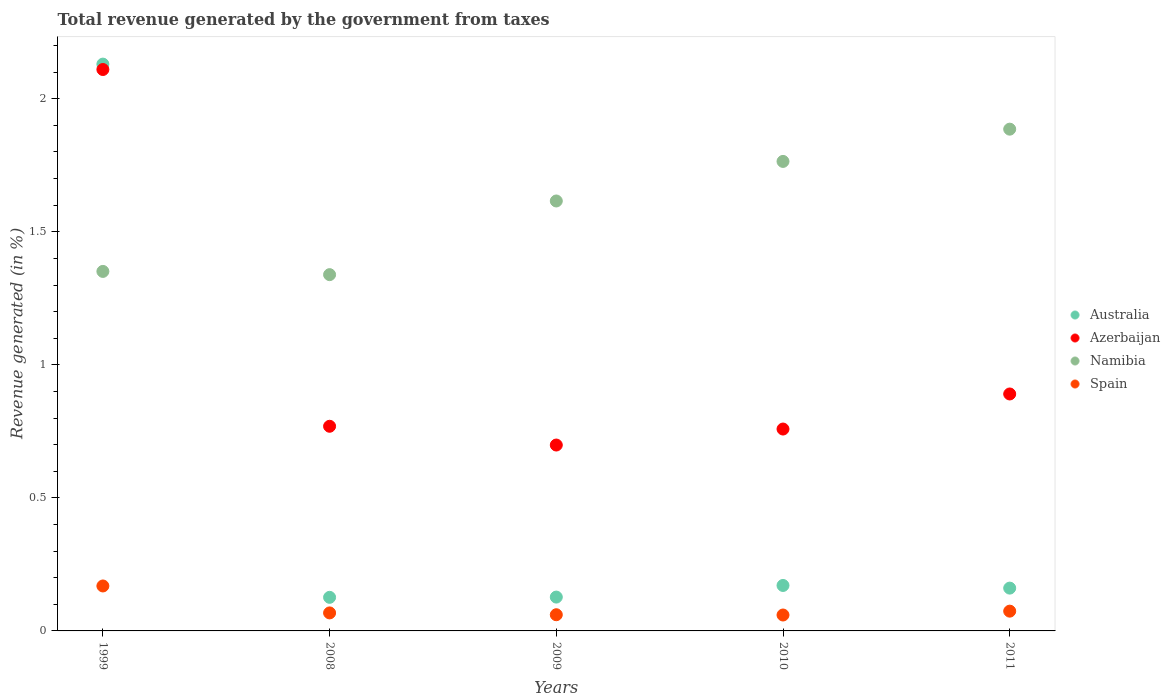Is the number of dotlines equal to the number of legend labels?
Your response must be concise. Yes. What is the total revenue generated in Spain in 1999?
Your answer should be very brief. 0.17. Across all years, what is the maximum total revenue generated in Namibia?
Keep it short and to the point. 1.89. Across all years, what is the minimum total revenue generated in Azerbaijan?
Your answer should be compact. 0.7. In which year was the total revenue generated in Spain maximum?
Your answer should be very brief. 1999. What is the total total revenue generated in Namibia in the graph?
Provide a succinct answer. 7.96. What is the difference between the total revenue generated in Australia in 2008 and that in 2011?
Offer a very short reply. -0.03. What is the difference between the total revenue generated in Australia in 2009 and the total revenue generated in Spain in 2008?
Your response must be concise. 0.06. What is the average total revenue generated in Azerbaijan per year?
Make the answer very short. 1.05. In the year 2008, what is the difference between the total revenue generated in Namibia and total revenue generated in Australia?
Your answer should be very brief. 1.21. In how many years, is the total revenue generated in Spain greater than 0.8 %?
Give a very brief answer. 0. What is the ratio of the total revenue generated in Australia in 2009 to that in 2011?
Your response must be concise. 0.79. Is the total revenue generated in Namibia in 2008 less than that in 2011?
Offer a terse response. Yes. What is the difference between the highest and the second highest total revenue generated in Spain?
Keep it short and to the point. 0.09. What is the difference between the highest and the lowest total revenue generated in Spain?
Give a very brief answer. 0.11. Is the sum of the total revenue generated in Australia in 2008 and 2011 greater than the maximum total revenue generated in Azerbaijan across all years?
Your answer should be very brief. No. Is the total revenue generated in Azerbaijan strictly greater than the total revenue generated in Spain over the years?
Your answer should be very brief. Yes. Is the total revenue generated in Spain strictly less than the total revenue generated in Australia over the years?
Provide a short and direct response. Yes. How many dotlines are there?
Your answer should be compact. 4. What is the difference between two consecutive major ticks on the Y-axis?
Ensure brevity in your answer.  0.5. Where does the legend appear in the graph?
Keep it short and to the point. Center right. What is the title of the graph?
Make the answer very short. Total revenue generated by the government from taxes. What is the label or title of the Y-axis?
Make the answer very short. Revenue generated (in %). What is the Revenue generated (in %) of Australia in 1999?
Your answer should be compact. 2.13. What is the Revenue generated (in %) in Azerbaijan in 1999?
Ensure brevity in your answer.  2.11. What is the Revenue generated (in %) of Namibia in 1999?
Make the answer very short. 1.35. What is the Revenue generated (in %) of Spain in 1999?
Give a very brief answer. 0.17. What is the Revenue generated (in %) in Australia in 2008?
Provide a short and direct response. 0.13. What is the Revenue generated (in %) of Azerbaijan in 2008?
Make the answer very short. 0.77. What is the Revenue generated (in %) of Namibia in 2008?
Keep it short and to the point. 1.34. What is the Revenue generated (in %) in Spain in 2008?
Ensure brevity in your answer.  0.07. What is the Revenue generated (in %) of Australia in 2009?
Your answer should be very brief. 0.13. What is the Revenue generated (in %) of Azerbaijan in 2009?
Offer a very short reply. 0.7. What is the Revenue generated (in %) of Namibia in 2009?
Your response must be concise. 1.62. What is the Revenue generated (in %) in Spain in 2009?
Give a very brief answer. 0.06. What is the Revenue generated (in %) of Australia in 2010?
Ensure brevity in your answer.  0.17. What is the Revenue generated (in %) in Azerbaijan in 2010?
Your answer should be very brief. 0.76. What is the Revenue generated (in %) of Namibia in 2010?
Offer a terse response. 1.76. What is the Revenue generated (in %) of Spain in 2010?
Ensure brevity in your answer.  0.06. What is the Revenue generated (in %) of Australia in 2011?
Ensure brevity in your answer.  0.16. What is the Revenue generated (in %) of Azerbaijan in 2011?
Your answer should be compact. 0.89. What is the Revenue generated (in %) of Namibia in 2011?
Offer a very short reply. 1.89. What is the Revenue generated (in %) in Spain in 2011?
Provide a short and direct response. 0.07. Across all years, what is the maximum Revenue generated (in %) in Australia?
Your answer should be very brief. 2.13. Across all years, what is the maximum Revenue generated (in %) of Azerbaijan?
Keep it short and to the point. 2.11. Across all years, what is the maximum Revenue generated (in %) in Namibia?
Ensure brevity in your answer.  1.89. Across all years, what is the maximum Revenue generated (in %) of Spain?
Your response must be concise. 0.17. Across all years, what is the minimum Revenue generated (in %) in Australia?
Your response must be concise. 0.13. Across all years, what is the minimum Revenue generated (in %) in Azerbaijan?
Give a very brief answer. 0.7. Across all years, what is the minimum Revenue generated (in %) of Namibia?
Your response must be concise. 1.34. Across all years, what is the minimum Revenue generated (in %) of Spain?
Your response must be concise. 0.06. What is the total Revenue generated (in %) of Australia in the graph?
Offer a very short reply. 2.72. What is the total Revenue generated (in %) in Azerbaijan in the graph?
Make the answer very short. 5.23. What is the total Revenue generated (in %) of Namibia in the graph?
Keep it short and to the point. 7.96. What is the total Revenue generated (in %) of Spain in the graph?
Your response must be concise. 0.43. What is the difference between the Revenue generated (in %) in Australia in 1999 and that in 2008?
Provide a short and direct response. 2. What is the difference between the Revenue generated (in %) in Azerbaijan in 1999 and that in 2008?
Provide a short and direct response. 1.34. What is the difference between the Revenue generated (in %) in Namibia in 1999 and that in 2008?
Provide a short and direct response. 0.01. What is the difference between the Revenue generated (in %) of Spain in 1999 and that in 2008?
Offer a very short reply. 0.1. What is the difference between the Revenue generated (in %) of Australia in 1999 and that in 2009?
Your answer should be very brief. 2. What is the difference between the Revenue generated (in %) of Azerbaijan in 1999 and that in 2009?
Provide a short and direct response. 1.41. What is the difference between the Revenue generated (in %) in Namibia in 1999 and that in 2009?
Make the answer very short. -0.26. What is the difference between the Revenue generated (in %) of Spain in 1999 and that in 2009?
Keep it short and to the point. 0.11. What is the difference between the Revenue generated (in %) of Australia in 1999 and that in 2010?
Provide a short and direct response. 1.96. What is the difference between the Revenue generated (in %) in Azerbaijan in 1999 and that in 2010?
Offer a terse response. 1.35. What is the difference between the Revenue generated (in %) in Namibia in 1999 and that in 2010?
Provide a short and direct response. -0.41. What is the difference between the Revenue generated (in %) of Spain in 1999 and that in 2010?
Make the answer very short. 0.11. What is the difference between the Revenue generated (in %) of Australia in 1999 and that in 2011?
Your response must be concise. 1.97. What is the difference between the Revenue generated (in %) in Azerbaijan in 1999 and that in 2011?
Provide a short and direct response. 1.22. What is the difference between the Revenue generated (in %) of Namibia in 1999 and that in 2011?
Make the answer very short. -0.53. What is the difference between the Revenue generated (in %) in Spain in 1999 and that in 2011?
Your response must be concise. 0.09. What is the difference between the Revenue generated (in %) of Australia in 2008 and that in 2009?
Provide a short and direct response. -0. What is the difference between the Revenue generated (in %) in Azerbaijan in 2008 and that in 2009?
Provide a succinct answer. 0.07. What is the difference between the Revenue generated (in %) in Namibia in 2008 and that in 2009?
Ensure brevity in your answer.  -0.28. What is the difference between the Revenue generated (in %) in Spain in 2008 and that in 2009?
Your answer should be compact. 0.01. What is the difference between the Revenue generated (in %) of Australia in 2008 and that in 2010?
Keep it short and to the point. -0.04. What is the difference between the Revenue generated (in %) in Azerbaijan in 2008 and that in 2010?
Your response must be concise. 0.01. What is the difference between the Revenue generated (in %) in Namibia in 2008 and that in 2010?
Your answer should be compact. -0.43. What is the difference between the Revenue generated (in %) of Spain in 2008 and that in 2010?
Make the answer very short. 0.01. What is the difference between the Revenue generated (in %) of Australia in 2008 and that in 2011?
Your answer should be compact. -0.03. What is the difference between the Revenue generated (in %) in Azerbaijan in 2008 and that in 2011?
Offer a terse response. -0.12. What is the difference between the Revenue generated (in %) in Namibia in 2008 and that in 2011?
Your answer should be very brief. -0.55. What is the difference between the Revenue generated (in %) in Spain in 2008 and that in 2011?
Your answer should be compact. -0.01. What is the difference between the Revenue generated (in %) in Australia in 2009 and that in 2010?
Offer a terse response. -0.04. What is the difference between the Revenue generated (in %) in Azerbaijan in 2009 and that in 2010?
Give a very brief answer. -0.06. What is the difference between the Revenue generated (in %) in Namibia in 2009 and that in 2010?
Give a very brief answer. -0.15. What is the difference between the Revenue generated (in %) of Australia in 2009 and that in 2011?
Ensure brevity in your answer.  -0.03. What is the difference between the Revenue generated (in %) in Azerbaijan in 2009 and that in 2011?
Make the answer very short. -0.19. What is the difference between the Revenue generated (in %) in Namibia in 2009 and that in 2011?
Give a very brief answer. -0.27. What is the difference between the Revenue generated (in %) in Spain in 2009 and that in 2011?
Offer a very short reply. -0.01. What is the difference between the Revenue generated (in %) in Australia in 2010 and that in 2011?
Your response must be concise. 0.01. What is the difference between the Revenue generated (in %) in Azerbaijan in 2010 and that in 2011?
Provide a succinct answer. -0.13. What is the difference between the Revenue generated (in %) in Namibia in 2010 and that in 2011?
Provide a short and direct response. -0.12. What is the difference between the Revenue generated (in %) of Spain in 2010 and that in 2011?
Offer a very short reply. -0.01. What is the difference between the Revenue generated (in %) of Australia in 1999 and the Revenue generated (in %) of Azerbaijan in 2008?
Your answer should be compact. 1.36. What is the difference between the Revenue generated (in %) in Australia in 1999 and the Revenue generated (in %) in Namibia in 2008?
Provide a succinct answer. 0.79. What is the difference between the Revenue generated (in %) of Australia in 1999 and the Revenue generated (in %) of Spain in 2008?
Ensure brevity in your answer.  2.06. What is the difference between the Revenue generated (in %) of Azerbaijan in 1999 and the Revenue generated (in %) of Namibia in 2008?
Ensure brevity in your answer.  0.77. What is the difference between the Revenue generated (in %) of Azerbaijan in 1999 and the Revenue generated (in %) of Spain in 2008?
Your answer should be very brief. 2.04. What is the difference between the Revenue generated (in %) in Namibia in 1999 and the Revenue generated (in %) in Spain in 2008?
Offer a very short reply. 1.28. What is the difference between the Revenue generated (in %) in Australia in 1999 and the Revenue generated (in %) in Azerbaijan in 2009?
Your answer should be very brief. 1.43. What is the difference between the Revenue generated (in %) of Australia in 1999 and the Revenue generated (in %) of Namibia in 2009?
Provide a succinct answer. 0.51. What is the difference between the Revenue generated (in %) of Australia in 1999 and the Revenue generated (in %) of Spain in 2009?
Keep it short and to the point. 2.07. What is the difference between the Revenue generated (in %) in Azerbaijan in 1999 and the Revenue generated (in %) in Namibia in 2009?
Offer a terse response. 0.49. What is the difference between the Revenue generated (in %) of Azerbaijan in 1999 and the Revenue generated (in %) of Spain in 2009?
Your answer should be very brief. 2.05. What is the difference between the Revenue generated (in %) of Namibia in 1999 and the Revenue generated (in %) of Spain in 2009?
Your response must be concise. 1.29. What is the difference between the Revenue generated (in %) in Australia in 1999 and the Revenue generated (in %) in Azerbaijan in 2010?
Ensure brevity in your answer.  1.37. What is the difference between the Revenue generated (in %) in Australia in 1999 and the Revenue generated (in %) in Namibia in 2010?
Make the answer very short. 0.37. What is the difference between the Revenue generated (in %) of Australia in 1999 and the Revenue generated (in %) of Spain in 2010?
Offer a terse response. 2.07. What is the difference between the Revenue generated (in %) in Azerbaijan in 1999 and the Revenue generated (in %) in Namibia in 2010?
Ensure brevity in your answer.  0.35. What is the difference between the Revenue generated (in %) of Azerbaijan in 1999 and the Revenue generated (in %) of Spain in 2010?
Offer a terse response. 2.05. What is the difference between the Revenue generated (in %) in Namibia in 1999 and the Revenue generated (in %) in Spain in 2010?
Provide a short and direct response. 1.29. What is the difference between the Revenue generated (in %) in Australia in 1999 and the Revenue generated (in %) in Azerbaijan in 2011?
Your answer should be compact. 1.24. What is the difference between the Revenue generated (in %) of Australia in 1999 and the Revenue generated (in %) of Namibia in 2011?
Make the answer very short. 0.24. What is the difference between the Revenue generated (in %) in Australia in 1999 and the Revenue generated (in %) in Spain in 2011?
Keep it short and to the point. 2.06. What is the difference between the Revenue generated (in %) in Azerbaijan in 1999 and the Revenue generated (in %) in Namibia in 2011?
Your answer should be compact. 0.22. What is the difference between the Revenue generated (in %) in Azerbaijan in 1999 and the Revenue generated (in %) in Spain in 2011?
Provide a short and direct response. 2.04. What is the difference between the Revenue generated (in %) of Namibia in 1999 and the Revenue generated (in %) of Spain in 2011?
Your response must be concise. 1.28. What is the difference between the Revenue generated (in %) in Australia in 2008 and the Revenue generated (in %) in Azerbaijan in 2009?
Offer a very short reply. -0.57. What is the difference between the Revenue generated (in %) in Australia in 2008 and the Revenue generated (in %) in Namibia in 2009?
Give a very brief answer. -1.49. What is the difference between the Revenue generated (in %) in Australia in 2008 and the Revenue generated (in %) in Spain in 2009?
Provide a short and direct response. 0.07. What is the difference between the Revenue generated (in %) of Azerbaijan in 2008 and the Revenue generated (in %) of Namibia in 2009?
Keep it short and to the point. -0.85. What is the difference between the Revenue generated (in %) of Azerbaijan in 2008 and the Revenue generated (in %) of Spain in 2009?
Provide a succinct answer. 0.71. What is the difference between the Revenue generated (in %) of Namibia in 2008 and the Revenue generated (in %) of Spain in 2009?
Offer a terse response. 1.28. What is the difference between the Revenue generated (in %) of Australia in 2008 and the Revenue generated (in %) of Azerbaijan in 2010?
Provide a short and direct response. -0.63. What is the difference between the Revenue generated (in %) in Australia in 2008 and the Revenue generated (in %) in Namibia in 2010?
Offer a very short reply. -1.64. What is the difference between the Revenue generated (in %) in Australia in 2008 and the Revenue generated (in %) in Spain in 2010?
Provide a short and direct response. 0.07. What is the difference between the Revenue generated (in %) in Azerbaijan in 2008 and the Revenue generated (in %) in Namibia in 2010?
Offer a terse response. -1. What is the difference between the Revenue generated (in %) in Azerbaijan in 2008 and the Revenue generated (in %) in Spain in 2010?
Make the answer very short. 0.71. What is the difference between the Revenue generated (in %) of Namibia in 2008 and the Revenue generated (in %) of Spain in 2010?
Keep it short and to the point. 1.28. What is the difference between the Revenue generated (in %) in Australia in 2008 and the Revenue generated (in %) in Azerbaijan in 2011?
Ensure brevity in your answer.  -0.76. What is the difference between the Revenue generated (in %) in Australia in 2008 and the Revenue generated (in %) in Namibia in 2011?
Make the answer very short. -1.76. What is the difference between the Revenue generated (in %) in Australia in 2008 and the Revenue generated (in %) in Spain in 2011?
Your answer should be very brief. 0.05. What is the difference between the Revenue generated (in %) in Azerbaijan in 2008 and the Revenue generated (in %) in Namibia in 2011?
Provide a short and direct response. -1.12. What is the difference between the Revenue generated (in %) of Azerbaijan in 2008 and the Revenue generated (in %) of Spain in 2011?
Your answer should be compact. 0.69. What is the difference between the Revenue generated (in %) of Namibia in 2008 and the Revenue generated (in %) of Spain in 2011?
Keep it short and to the point. 1.26. What is the difference between the Revenue generated (in %) of Australia in 2009 and the Revenue generated (in %) of Azerbaijan in 2010?
Keep it short and to the point. -0.63. What is the difference between the Revenue generated (in %) of Australia in 2009 and the Revenue generated (in %) of Namibia in 2010?
Your answer should be very brief. -1.64. What is the difference between the Revenue generated (in %) of Australia in 2009 and the Revenue generated (in %) of Spain in 2010?
Offer a terse response. 0.07. What is the difference between the Revenue generated (in %) in Azerbaijan in 2009 and the Revenue generated (in %) in Namibia in 2010?
Make the answer very short. -1.07. What is the difference between the Revenue generated (in %) of Azerbaijan in 2009 and the Revenue generated (in %) of Spain in 2010?
Provide a short and direct response. 0.64. What is the difference between the Revenue generated (in %) in Namibia in 2009 and the Revenue generated (in %) in Spain in 2010?
Give a very brief answer. 1.56. What is the difference between the Revenue generated (in %) of Australia in 2009 and the Revenue generated (in %) of Azerbaijan in 2011?
Provide a succinct answer. -0.76. What is the difference between the Revenue generated (in %) of Australia in 2009 and the Revenue generated (in %) of Namibia in 2011?
Make the answer very short. -1.76. What is the difference between the Revenue generated (in %) in Australia in 2009 and the Revenue generated (in %) in Spain in 2011?
Your response must be concise. 0.05. What is the difference between the Revenue generated (in %) of Azerbaijan in 2009 and the Revenue generated (in %) of Namibia in 2011?
Your response must be concise. -1.19. What is the difference between the Revenue generated (in %) in Azerbaijan in 2009 and the Revenue generated (in %) in Spain in 2011?
Your answer should be very brief. 0.62. What is the difference between the Revenue generated (in %) of Namibia in 2009 and the Revenue generated (in %) of Spain in 2011?
Your answer should be compact. 1.54. What is the difference between the Revenue generated (in %) of Australia in 2010 and the Revenue generated (in %) of Azerbaijan in 2011?
Make the answer very short. -0.72. What is the difference between the Revenue generated (in %) of Australia in 2010 and the Revenue generated (in %) of Namibia in 2011?
Provide a succinct answer. -1.71. What is the difference between the Revenue generated (in %) in Australia in 2010 and the Revenue generated (in %) in Spain in 2011?
Your answer should be compact. 0.1. What is the difference between the Revenue generated (in %) of Azerbaijan in 2010 and the Revenue generated (in %) of Namibia in 2011?
Keep it short and to the point. -1.13. What is the difference between the Revenue generated (in %) in Azerbaijan in 2010 and the Revenue generated (in %) in Spain in 2011?
Provide a succinct answer. 0.68. What is the difference between the Revenue generated (in %) in Namibia in 2010 and the Revenue generated (in %) in Spain in 2011?
Your response must be concise. 1.69. What is the average Revenue generated (in %) in Australia per year?
Keep it short and to the point. 0.54. What is the average Revenue generated (in %) in Azerbaijan per year?
Keep it short and to the point. 1.05. What is the average Revenue generated (in %) of Namibia per year?
Offer a very short reply. 1.59. What is the average Revenue generated (in %) in Spain per year?
Your response must be concise. 0.09. In the year 1999, what is the difference between the Revenue generated (in %) of Australia and Revenue generated (in %) of Azerbaijan?
Your answer should be very brief. 0.02. In the year 1999, what is the difference between the Revenue generated (in %) in Australia and Revenue generated (in %) in Namibia?
Provide a succinct answer. 0.78. In the year 1999, what is the difference between the Revenue generated (in %) in Australia and Revenue generated (in %) in Spain?
Your response must be concise. 1.96. In the year 1999, what is the difference between the Revenue generated (in %) of Azerbaijan and Revenue generated (in %) of Namibia?
Your response must be concise. 0.76. In the year 1999, what is the difference between the Revenue generated (in %) in Azerbaijan and Revenue generated (in %) in Spain?
Offer a terse response. 1.94. In the year 1999, what is the difference between the Revenue generated (in %) of Namibia and Revenue generated (in %) of Spain?
Keep it short and to the point. 1.18. In the year 2008, what is the difference between the Revenue generated (in %) in Australia and Revenue generated (in %) in Azerbaijan?
Make the answer very short. -0.64. In the year 2008, what is the difference between the Revenue generated (in %) in Australia and Revenue generated (in %) in Namibia?
Offer a very short reply. -1.21. In the year 2008, what is the difference between the Revenue generated (in %) in Australia and Revenue generated (in %) in Spain?
Give a very brief answer. 0.06. In the year 2008, what is the difference between the Revenue generated (in %) in Azerbaijan and Revenue generated (in %) in Namibia?
Offer a very short reply. -0.57. In the year 2008, what is the difference between the Revenue generated (in %) of Azerbaijan and Revenue generated (in %) of Spain?
Make the answer very short. 0.7. In the year 2008, what is the difference between the Revenue generated (in %) of Namibia and Revenue generated (in %) of Spain?
Give a very brief answer. 1.27. In the year 2009, what is the difference between the Revenue generated (in %) in Australia and Revenue generated (in %) in Azerbaijan?
Keep it short and to the point. -0.57. In the year 2009, what is the difference between the Revenue generated (in %) of Australia and Revenue generated (in %) of Namibia?
Provide a succinct answer. -1.49. In the year 2009, what is the difference between the Revenue generated (in %) of Australia and Revenue generated (in %) of Spain?
Ensure brevity in your answer.  0.07. In the year 2009, what is the difference between the Revenue generated (in %) of Azerbaijan and Revenue generated (in %) of Namibia?
Make the answer very short. -0.92. In the year 2009, what is the difference between the Revenue generated (in %) of Azerbaijan and Revenue generated (in %) of Spain?
Your response must be concise. 0.64. In the year 2009, what is the difference between the Revenue generated (in %) in Namibia and Revenue generated (in %) in Spain?
Offer a very short reply. 1.55. In the year 2010, what is the difference between the Revenue generated (in %) of Australia and Revenue generated (in %) of Azerbaijan?
Ensure brevity in your answer.  -0.59. In the year 2010, what is the difference between the Revenue generated (in %) in Australia and Revenue generated (in %) in Namibia?
Give a very brief answer. -1.59. In the year 2010, what is the difference between the Revenue generated (in %) in Australia and Revenue generated (in %) in Spain?
Give a very brief answer. 0.11. In the year 2010, what is the difference between the Revenue generated (in %) of Azerbaijan and Revenue generated (in %) of Namibia?
Ensure brevity in your answer.  -1.01. In the year 2010, what is the difference between the Revenue generated (in %) of Azerbaijan and Revenue generated (in %) of Spain?
Provide a succinct answer. 0.7. In the year 2010, what is the difference between the Revenue generated (in %) in Namibia and Revenue generated (in %) in Spain?
Keep it short and to the point. 1.7. In the year 2011, what is the difference between the Revenue generated (in %) of Australia and Revenue generated (in %) of Azerbaijan?
Your response must be concise. -0.73. In the year 2011, what is the difference between the Revenue generated (in %) in Australia and Revenue generated (in %) in Namibia?
Your answer should be compact. -1.72. In the year 2011, what is the difference between the Revenue generated (in %) in Australia and Revenue generated (in %) in Spain?
Ensure brevity in your answer.  0.09. In the year 2011, what is the difference between the Revenue generated (in %) of Azerbaijan and Revenue generated (in %) of Namibia?
Make the answer very short. -1. In the year 2011, what is the difference between the Revenue generated (in %) in Azerbaijan and Revenue generated (in %) in Spain?
Give a very brief answer. 0.82. In the year 2011, what is the difference between the Revenue generated (in %) in Namibia and Revenue generated (in %) in Spain?
Make the answer very short. 1.81. What is the ratio of the Revenue generated (in %) in Australia in 1999 to that in 2008?
Give a very brief answer. 16.88. What is the ratio of the Revenue generated (in %) of Azerbaijan in 1999 to that in 2008?
Make the answer very short. 2.74. What is the ratio of the Revenue generated (in %) of Namibia in 1999 to that in 2008?
Offer a very short reply. 1.01. What is the ratio of the Revenue generated (in %) of Spain in 1999 to that in 2008?
Your answer should be very brief. 2.5. What is the ratio of the Revenue generated (in %) in Australia in 1999 to that in 2009?
Ensure brevity in your answer.  16.75. What is the ratio of the Revenue generated (in %) of Azerbaijan in 1999 to that in 2009?
Provide a short and direct response. 3.02. What is the ratio of the Revenue generated (in %) in Namibia in 1999 to that in 2009?
Your answer should be compact. 0.84. What is the ratio of the Revenue generated (in %) in Spain in 1999 to that in 2009?
Your answer should be very brief. 2.78. What is the ratio of the Revenue generated (in %) of Australia in 1999 to that in 2010?
Make the answer very short. 12.47. What is the ratio of the Revenue generated (in %) in Azerbaijan in 1999 to that in 2010?
Ensure brevity in your answer.  2.78. What is the ratio of the Revenue generated (in %) of Namibia in 1999 to that in 2010?
Provide a short and direct response. 0.77. What is the ratio of the Revenue generated (in %) of Spain in 1999 to that in 2010?
Your response must be concise. 2.82. What is the ratio of the Revenue generated (in %) in Australia in 1999 to that in 2011?
Make the answer very short. 13.24. What is the ratio of the Revenue generated (in %) in Azerbaijan in 1999 to that in 2011?
Offer a terse response. 2.37. What is the ratio of the Revenue generated (in %) of Namibia in 1999 to that in 2011?
Make the answer very short. 0.72. What is the ratio of the Revenue generated (in %) in Spain in 1999 to that in 2011?
Provide a short and direct response. 2.27. What is the ratio of the Revenue generated (in %) in Australia in 2008 to that in 2009?
Your answer should be compact. 0.99. What is the ratio of the Revenue generated (in %) of Azerbaijan in 2008 to that in 2009?
Provide a short and direct response. 1.1. What is the ratio of the Revenue generated (in %) in Namibia in 2008 to that in 2009?
Ensure brevity in your answer.  0.83. What is the ratio of the Revenue generated (in %) of Spain in 2008 to that in 2009?
Provide a succinct answer. 1.11. What is the ratio of the Revenue generated (in %) in Australia in 2008 to that in 2010?
Offer a terse response. 0.74. What is the ratio of the Revenue generated (in %) of Azerbaijan in 2008 to that in 2010?
Provide a short and direct response. 1.01. What is the ratio of the Revenue generated (in %) of Namibia in 2008 to that in 2010?
Offer a very short reply. 0.76. What is the ratio of the Revenue generated (in %) of Spain in 2008 to that in 2010?
Ensure brevity in your answer.  1.13. What is the ratio of the Revenue generated (in %) of Australia in 2008 to that in 2011?
Make the answer very short. 0.78. What is the ratio of the Revenue generated (in %) in Azerbaijan in 2008 to that in 2011?
Offer a terse response. 0.86. What is the ratio of the Revenue generated (in %) of Namibia in 2008 to that in 2011?
Your response must be concise. 0.71. What is the ratio of the Revenue generated (in %) of Spain in 2008 to that in 2011?
Keep it short and to the point. 0.91. What is the ratio of the Revenue generated (in %) in Australia in 2009 to that in 2010?
Provide a succinct answer. 0.74. What is the ratio of the Revenue generated (in %) of Azerbaijan in 2009 to that in 2010?
Provide a short and direct response. 0.92. What is the ratio of the Revenue generated (in %) of Namibia in 2009 to that in 2010?
Ensure brevity in your answer.  0.92. What is the ratio of the Revenue generated (in %) of Spain in 2009 to that in 2010?
Your answer should be very brief. 1.02. What is the ratio of the Revenue generated (in %) of Australia in 2009 to that in 2011?
Your answer should be compact. 0.79. What is the ratio of the Revenue generated (in %) in Azerbaijan in 2009 to that in 2011?
Make the answer very short. 0.78. What is the ratio of the Revenue generated (in %) of Namibia in 2009 to that in 2011?
Your response must be concise. 0.86. What is the ratio of the Revenue generated (in %) in Spain in 2009 to that in 2011?
Your answer should be compact. 0.82. What is the ratio of the Revenue generated (in %) of Australia in 2010 to that in 2011?
Your answer should be very brief. 1.06. What is the ratio of the Revenue generated (in %) of Azerbaijan in 2010 to that in 2011?
Provide a succinct answer. 0.85. What is the ratio of the Revenue generated (in %) in Namibia in 2010 to that in 2011?
Offer a terse response. 0.94. What is the ratio of the Revenue generated (in %) of Spain in 2010 to that in 2011?
Offer a very short reply. 0.81. What is the difference between the highest and the second highest Revenue generated (in %) of Australia?
Keep it short and to the point. 1.96. What is the difference between the highest and the second highest Revenue generated (in %) of Azerbaijan?
Offer a terse response. 1.22. What is the difference between the highest and the second highest Revenue generated (in %) in Namibia?
Provide a short and direct response. 0.12. What is the difference between the highest and the second highest Revenue generated (in %) of Spain?
Keep it short and to the point. 0.09. What is the difference between the highest and the lowest Revenue generated (in %) in Australia?
Offer a very short reply. 2. What is the difference between the highest and the lowest Revenue generated (in %) in Azerbaijan?
Your answer should be compact. 1.41. What is the difference between the highest and the lowest Revenue generated (in %) in Namibia?
Offer a very short reply. 0.55. What is the difference between the highest and the lowest Revenue generated (in %) in Spain?
Give a very brief answer. 0.11. 